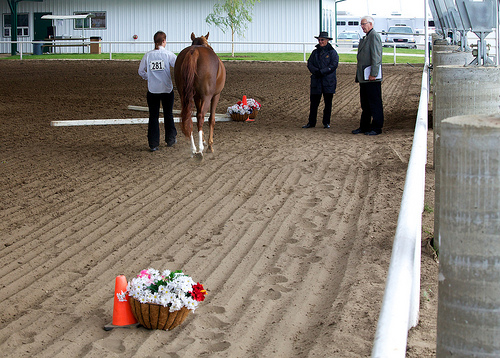<image>
Is there a horse on the sand? Yes. Looking at the image, I can see the horse is positioned on top of the sand, with the sand providing support. Is there a flower behind the horse? Yes. From this viewpoint, the flower is positioned behind the horse, with the horse partially or fully occluding the flower. Is there a fence behind the horse? No. The fence is not behind the horse. From this viewpoint, the fence appears to be positioned elsewhere in the scene. 